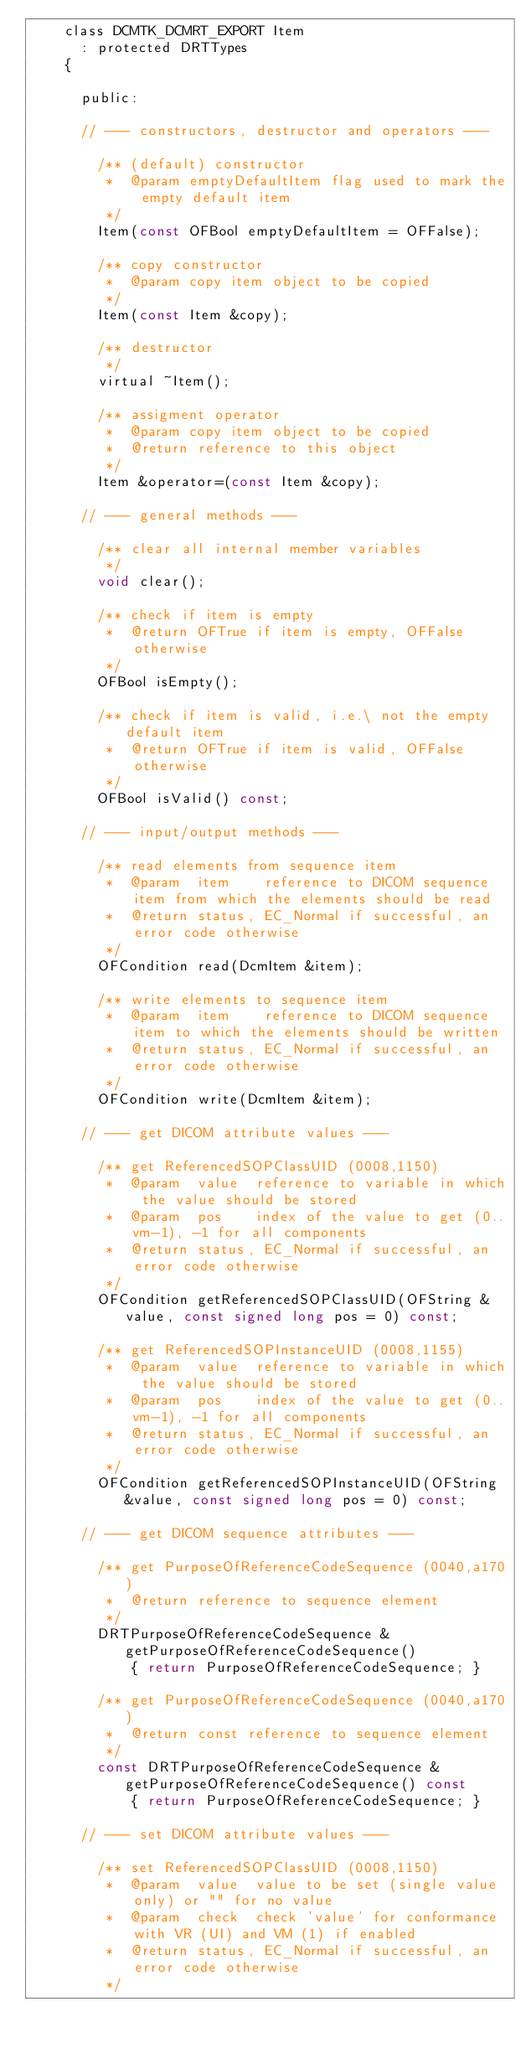<code> <loc_0><loc_0><loc_500><loc_500><_C_>    class DCMTK_DCMRT_EXPORT Item
      : protected DRTTypes
    {

      public:

      // --- constructors, destructor and operators ---

        /** (default) constructor
         *  @param emptyDefaultItem flag used to mark the empty default item
         */
        Item(const OFBool emptyDefaultItem = OFFalse);

        /** copy constructor
         *  @param copy item object to be copied
         */
        Item(const Item &copy);

        /** destructor
         */
        virtual ~Item();

        /** assigment operator
         *  @param copy item object to be copied
         *  @return reference to this object
         */
        Item &operator=(const Item &copy);

      // --- general methods ---

        /** clear all internal member variables
         */
        void clear();

        /** check if item is empty
         *  @return OFTrue if item is empty, OFFalse otherwise
         */
        OFBool isEmpty();

        /** check if item is valid, i.e.\ not the empty default item
         *  @return OFTrue if item is valid, OFFalse otherwise
         */
        OFBool isValid() const;

      // --- input/output methods ---

        /** read elements from sequence item
         *  @param  item    reference to DICOM sequence item from which the elements should be read
         *  @return status, EC_Normal if successful, an error code otherwise
         */
        OFCondition read(DcmItem &item);

        /** write elements to sequence item
         *  @param  item    reference to DICOM sequence item to which the elements should be written
         *  @return status, EC_Normal if successful, an error code otherwise
         */
        OFCondition write(DcmItem &item);

      // --- get DICOM attribute values ---

        /** get ReferencedSOPClassUID (0008,1150)
         *  @param  value  reference to variable in which the value should be stored
         *  @param  pos    index of the value to get (0..vm-1), -1 for all components
         *  @return status, EC_Normal if successful, an error code otherwise
         */
        OFCondition getReferencedSOPClassUID(OFString &value, const signed long pos = 0) const;

        /** get ReferencedSOPInstanceUID (0008,1155)
         *  @param  value  reference to variable in which the value should be stored
         *  @param  pos    index of the value to get (0..vm-1), -1 for all components
         *  @return status, EC_Normal if successful, an error code otherwise
         */
        OFCondition getReferencedSOPInstanceUID(OFString &value, const signed long pos = 0) const;

      // --- get DICOM sequence attributes ---

        /** get PurposeOfReferenceCodeSequence (0040,a170)
         *  @return reference to sequence element
         */
        DRTPurposeOfReferenceCodeSequence &getPurposeOfReferenceCodeSequence()
            { return PurposeOfReferenceCodeSequence; }

        /** get PurposeOfReferenceCodeSequence (0040,a170)
         *  @return const reference to sequence element
         */
        const DRTPurposeOfReferenceCodeSequence &getPurposeOfReferenceCodeSequence() const
            { return PurposeOfReferenceCodeSequence; }

      // --- set DICOM attribute values ---

        /** set ReferencedSOPClassUID (0008,1150)
         *  @param  value  value to be set (single value only) or "" for no value
         *  @param  check  check 'value' for conformance with VR (UI) and VM (1) if enabled
         *  @return status, EC_Normal if successful, an error code otherwise
         */</code> 